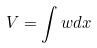Convert formula to latex. <formula><loc_0><loc_0><loc_500><loc_500>V = \int w d x</formula> 